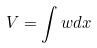Convert formula to latex. <formula><loc_0><loc_0><loc_500><loc_500>V = \int w d x</formula> 